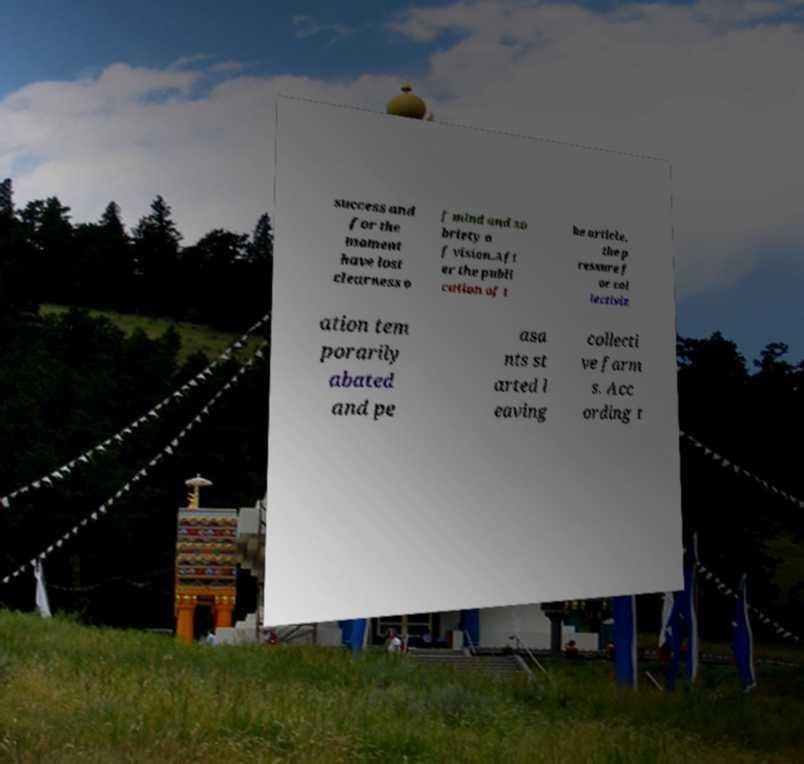For documentation purposes, I need the text within this image transcribed. Could you provide that? success and for the moment have lost clearness o f mind and so briety o f vision.Aft er the publi cation of t he article, the p ressure f or col lectiviz ation tem porarily abated and pe asa nts st arted l eaving collecti ve farm s. Acc ording t 